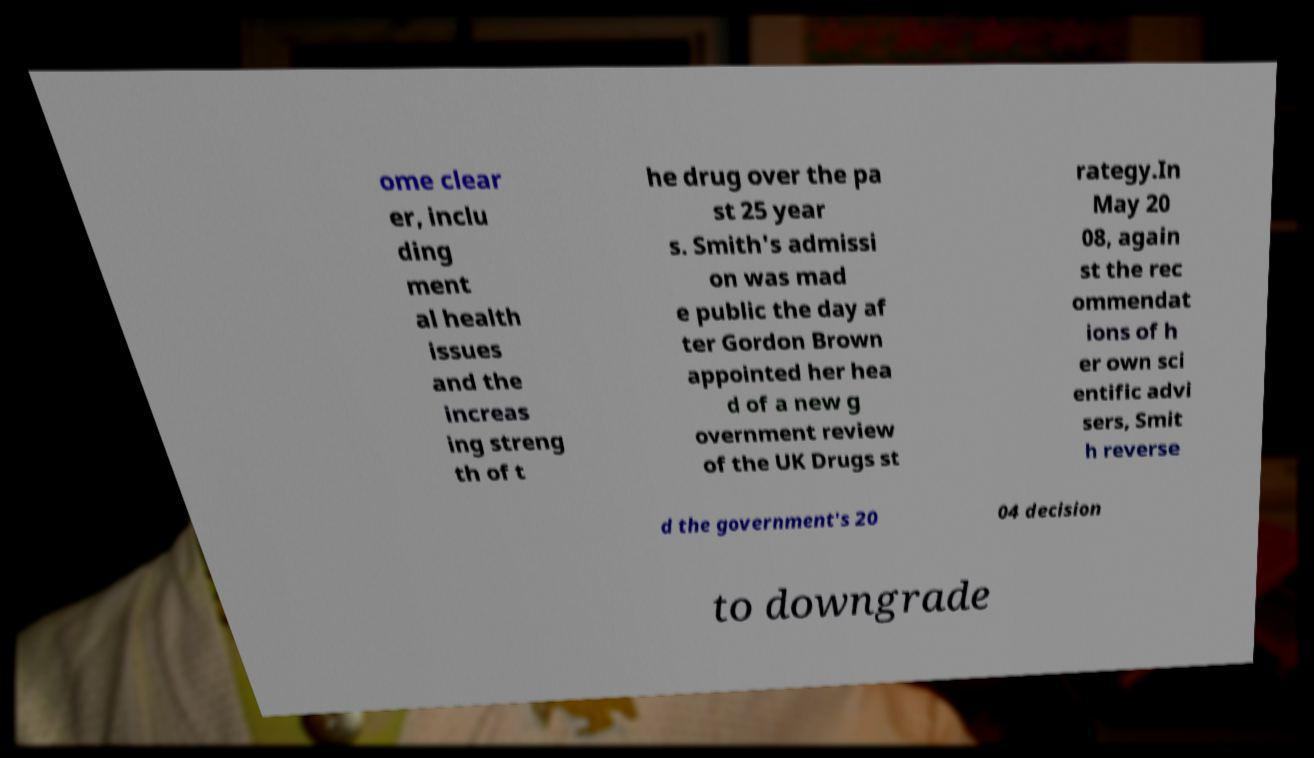Could you extract and type out the text from this image? ome clear er, inclu ding ment al health issues and the increas ing streng th of t he drug over the pa st 25 year s. Smith's admissi on was mad e public the day af ter Gordon Brown appointed her hea d of a new g overnment review of the UK Drugs st rategy.In May 20 08, again st the rec ommendat ions of h er own sci entific advi sers, Smit h reverse d the government's 20 04 decision to downgrade 